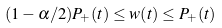<formula> <loc_0><loc_0><loc_500><loc_500>( 1 - \alpha / 2 ) P _ { + } ( t ) \leq w ( t ) \leq P _ { + } ( t )</formula> 